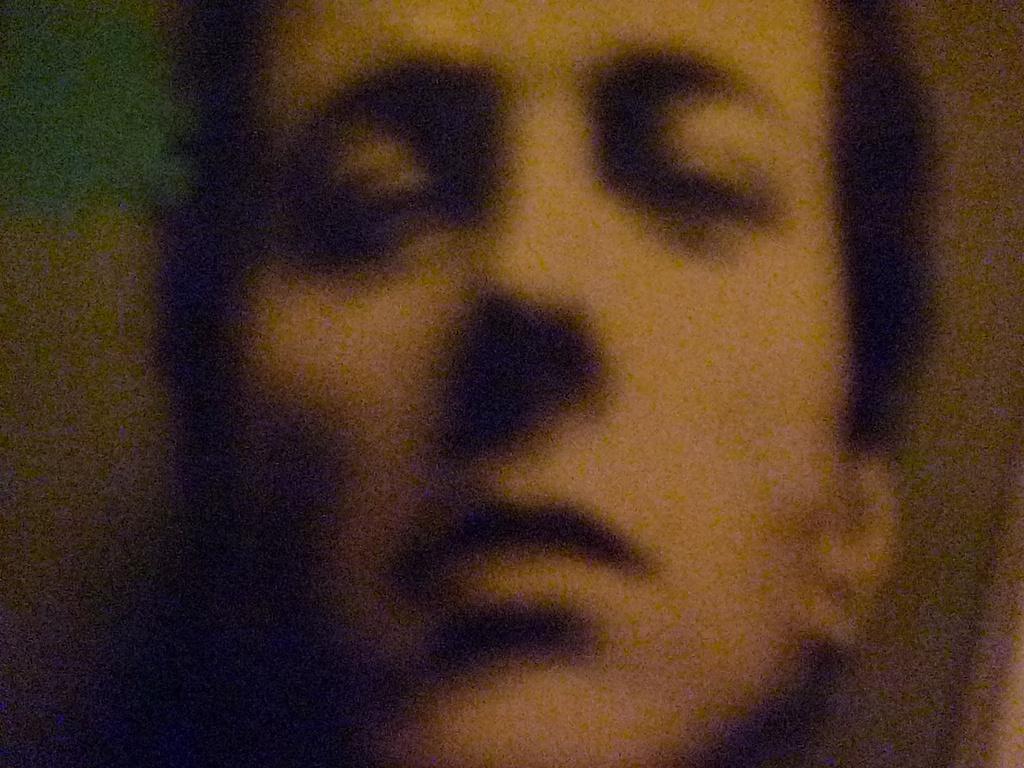Please provide a concise description of this image. In this image I can see the person's face and I can see the blurred background. 